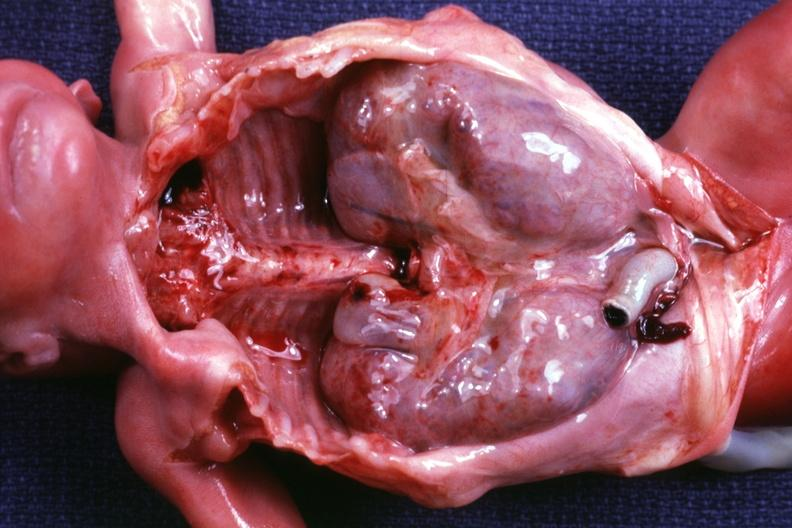what is other organs removed?
Answer the question using a single word or phrase. Dramatic demonstration of size of kidneys 